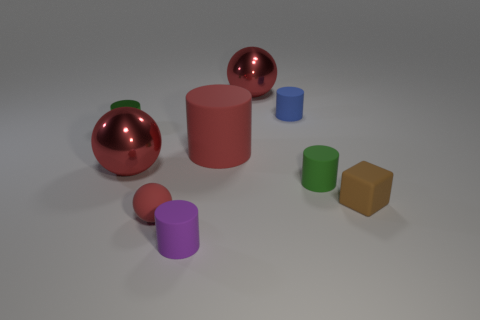What is the material of the cube that is the same size as the blue matte object?
Your answer should be very brief. Rubber. Does the purple cylinder have the same material as the big red cylinder?
Ensure brevity in your answer.  Yes. There is a tiny rubber object that is behind the tiny rubber block and in front of the tiny blue cylinder; what is its color?
Provide a short and direct response. Green. There is a tiny matte cylinder that is in front of the brown rubber cube; does it have the same color as the small matte ball?
Ensure brevity in your answer.  No. What shape is the brown thing that is the same size as the green metal cylinder?
Provide a succinct answer. Cube. How many other things are there of the same color as the block?
Give a very brief answer. 0. How many other things are there of the same material as the brown thing?
Your response must be concise. 5. Do the cube and the red ball left of the tiny red object have the same size?
Give a very brief answer. No. The large cylinder has what color?
Ensure brevity in your answer.  Red. The tiny rubber thing that is in front of the ball that is in front of the green object that is on the right side of the tiny shiny cylinder is what shape?
Ensure brevity in your answer.  Cylinder. 